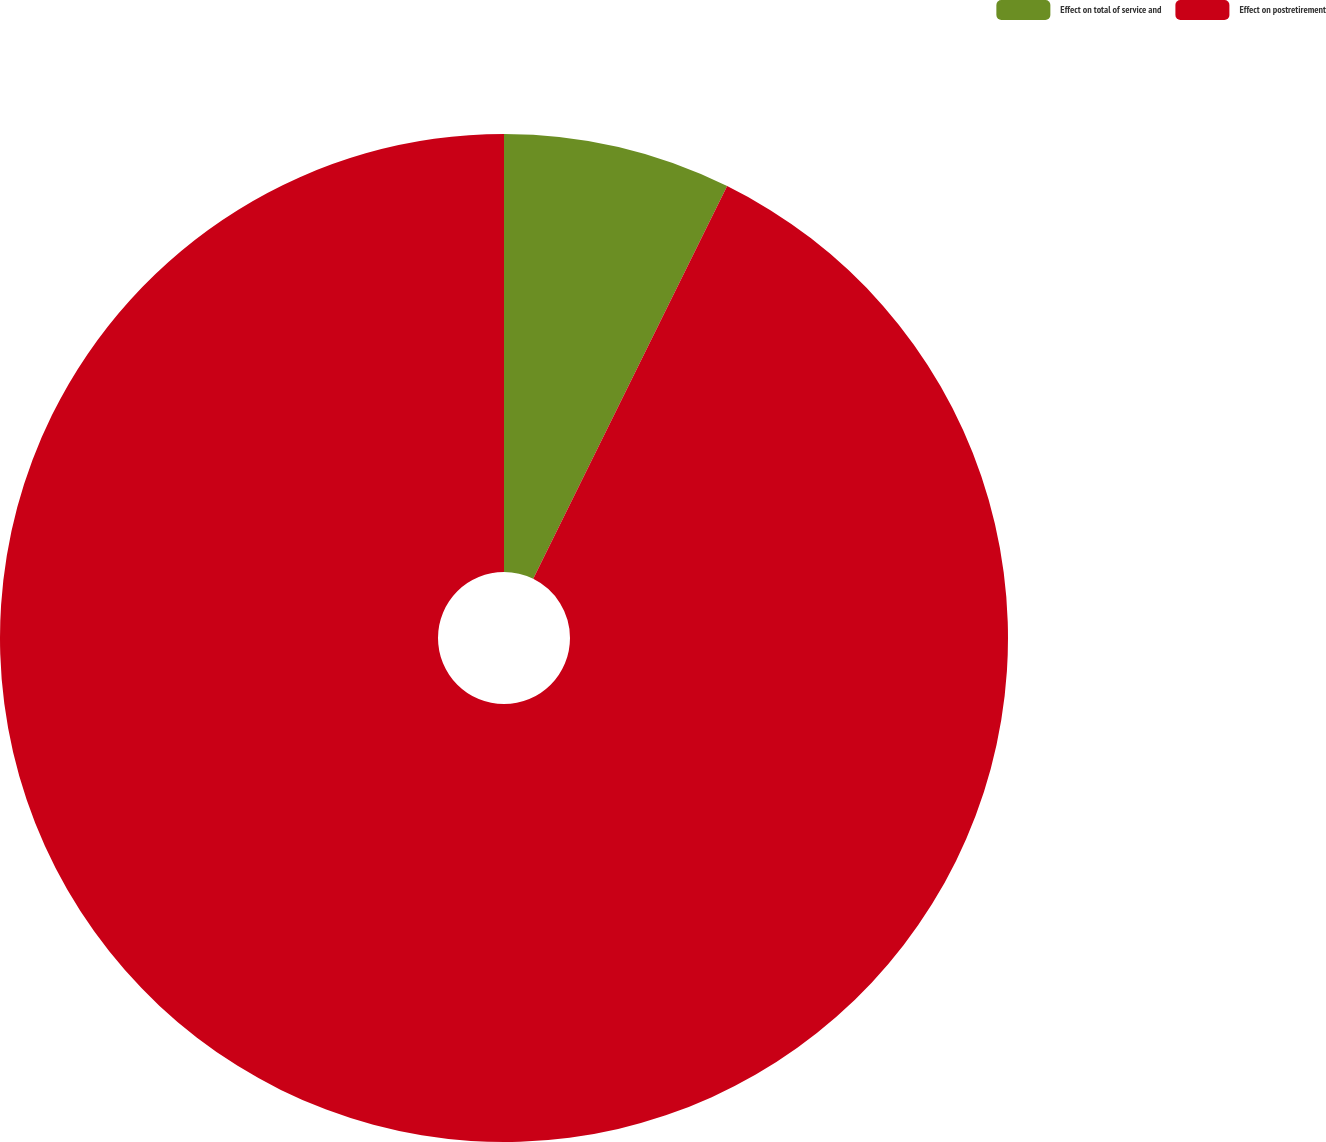Convert chart to OTSL. <chart><loc_0><loc_0><loc_500><loc_500><pie_chart><fcel>Effect on total of service and<fcel>Effect on postretirement<nl><fcel>7.3%<fcel>92.7%<nl></chart> 